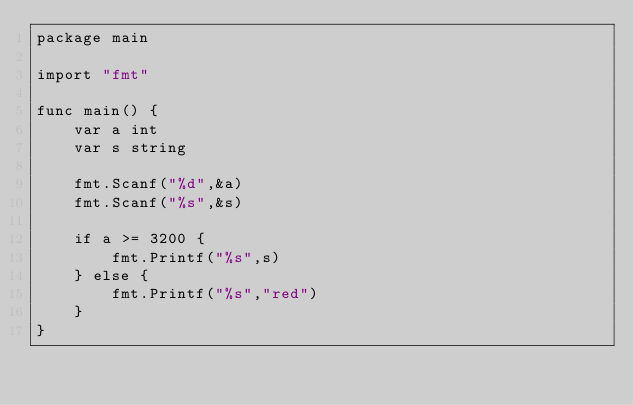<code> <loc_0><loc_0><loc_500><loc_500><_Go_>package main

import "fmt"

func main() {
	var a int
	var s string
	
	fmt.Scanf("%d",&a)
	fmt.Scanf("%s",&s)
	
	if a >= 3200 {
		fmt.Printf("%s",s)
	} else {
		fmt.Printf("%s","red")
	}
}</code> 